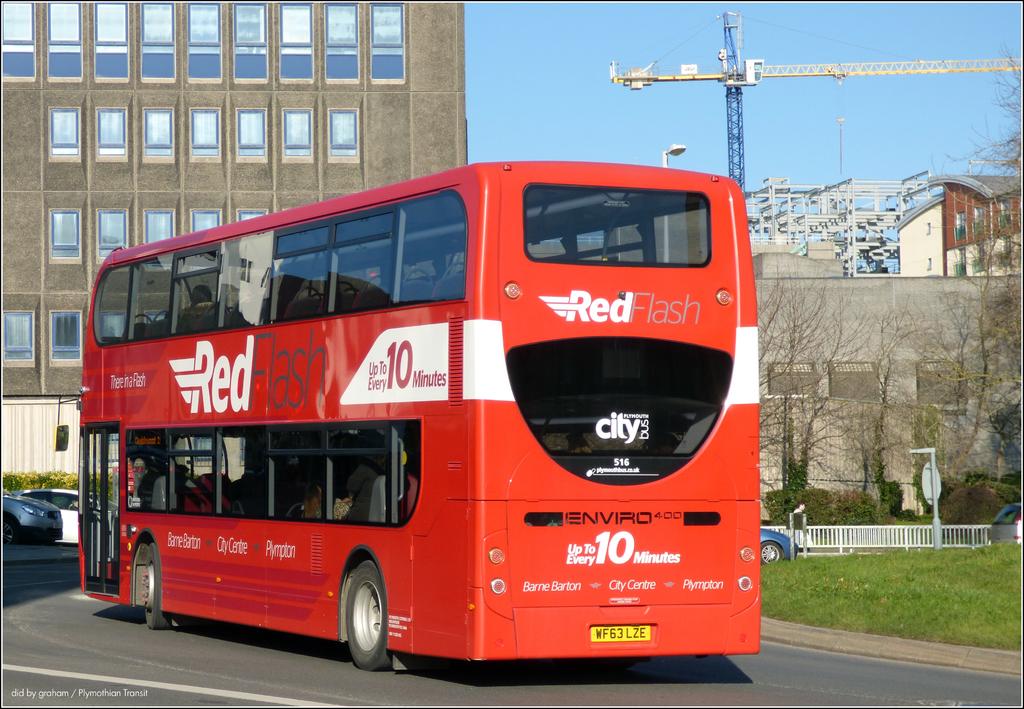What is the name of the bus company?
Your answer should be very brief. Red flash. How many minutes?
Ensure brevity in your answer.  10. 